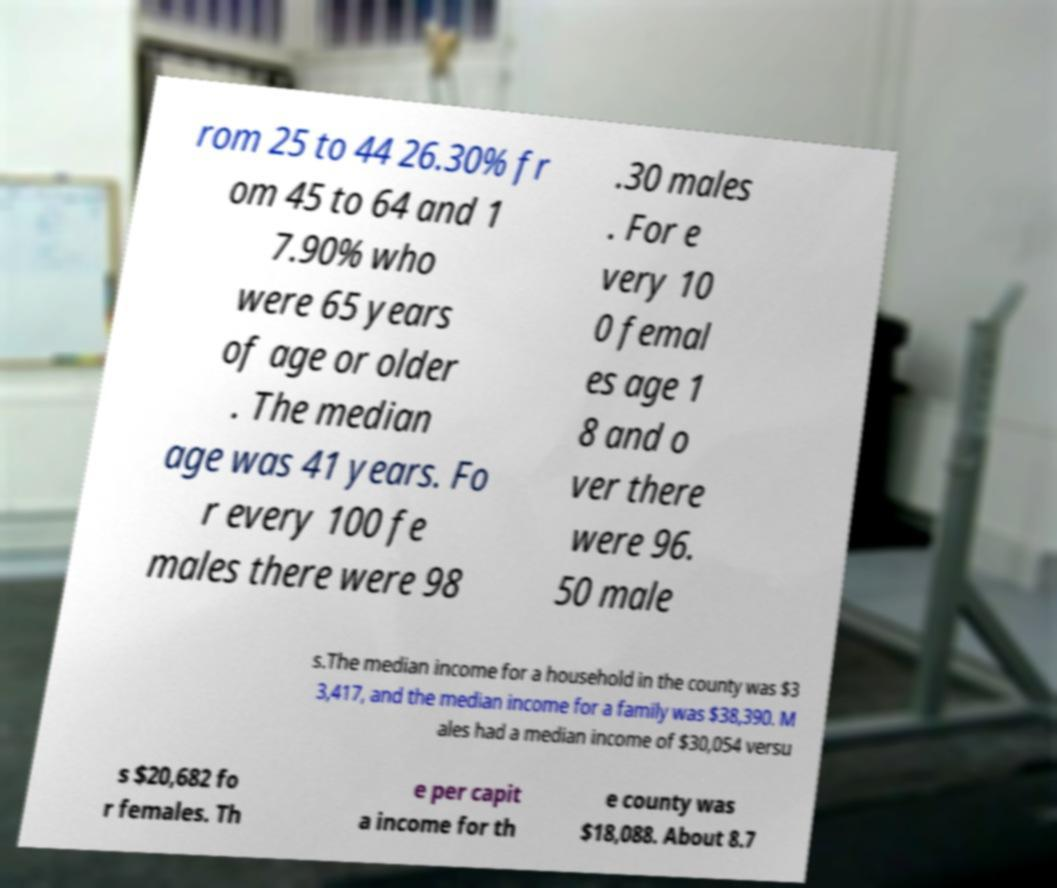Please identify and transcribe the text found in this image. rom 25 to 44 26.30% fr om 45 to 64 and 1 7.90% who were 65 years of age or older . The median age was 41 years. Fo r every 100 fe males there were 98 .30 males . For e very 10 0 femal es age 1 8 and o ver there were 96. 50 male s.The median income for a household in the county was $3 3,417, and the median income for a family was $38,390. M ales had a median income of $30,054 versu s $20,682 fo r females. Th e per capit a income for th e county was $18,088. About 8.7 